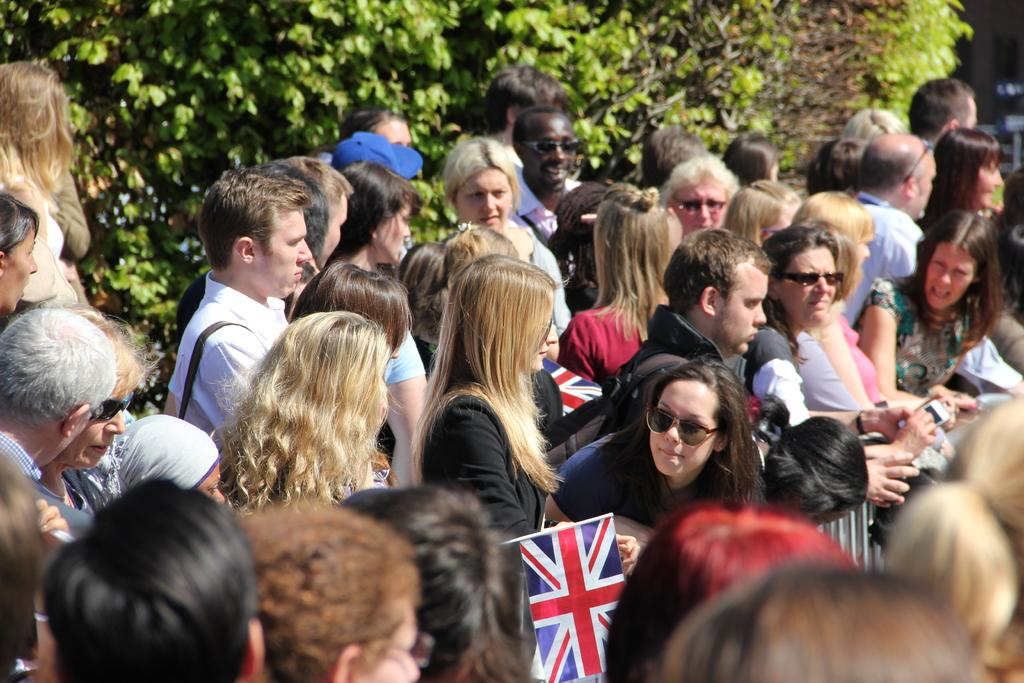How many people can be seen in the image? There are many people standing in the image. What can be seen in the background of the image? There are plants visible in the background of the image. What type of beam is being used by the people in the image? There is no beam present in the image; it only shows people standing and plants in the background. 